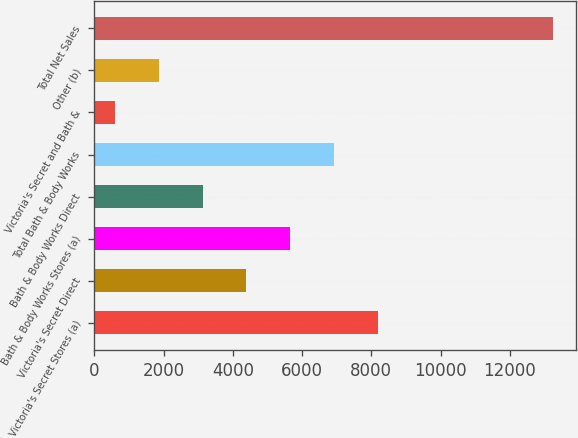<chart> <loc_0><loc_0><loc_500><loc_500><bar_chart><fcel>Victoria's Secret Stores (a)<fcel>Victoria's Secret Direct<fcel>Bath & Body Works Stores (a)<fcel>Bath & Body Works Direct<fcel>Total Bath & Body Works<fcel>Victoria's Secret and Bath &<fcel>Other (b)<fcel>Total Net Sales<nl><fcel>8184.2<fcel>4394.6<fcel>5657.8<fcel>3131.4<fcel>6921<fcel>605<fcel>1868.2<fcel>13237<nl></chart> 